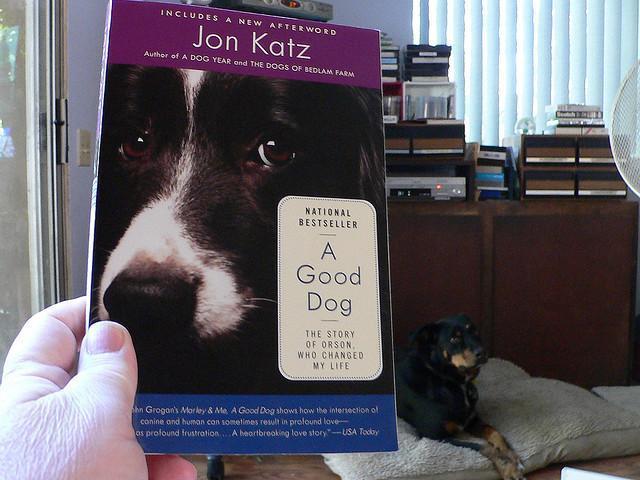How many dogs are pictured?
Give a very brief answer. 2. How many beds can be seen?
Give a very brief answer. 1. How many dogs are there?
Give a very brief answer. 2. How many cats with spots do you see?
Give a very brief answer. 0. 